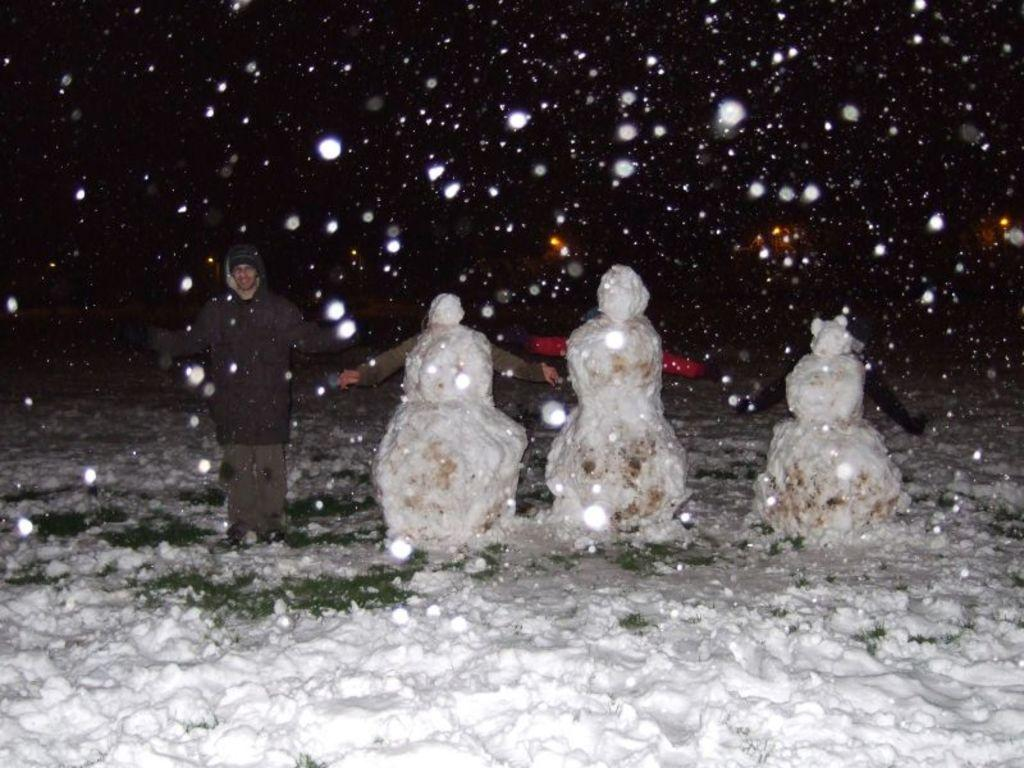What is the person standing in the image? There is a person standing in the snow in the image. What else can be seen on the ground in the image? There are snowmen on the path in the image. What type of whip is the person holding in the image? There is no whip present in the image; the person is standing in the snow. What is the person using to carry items in the image? There is no basket or any indication of the person carrying items in the image. 